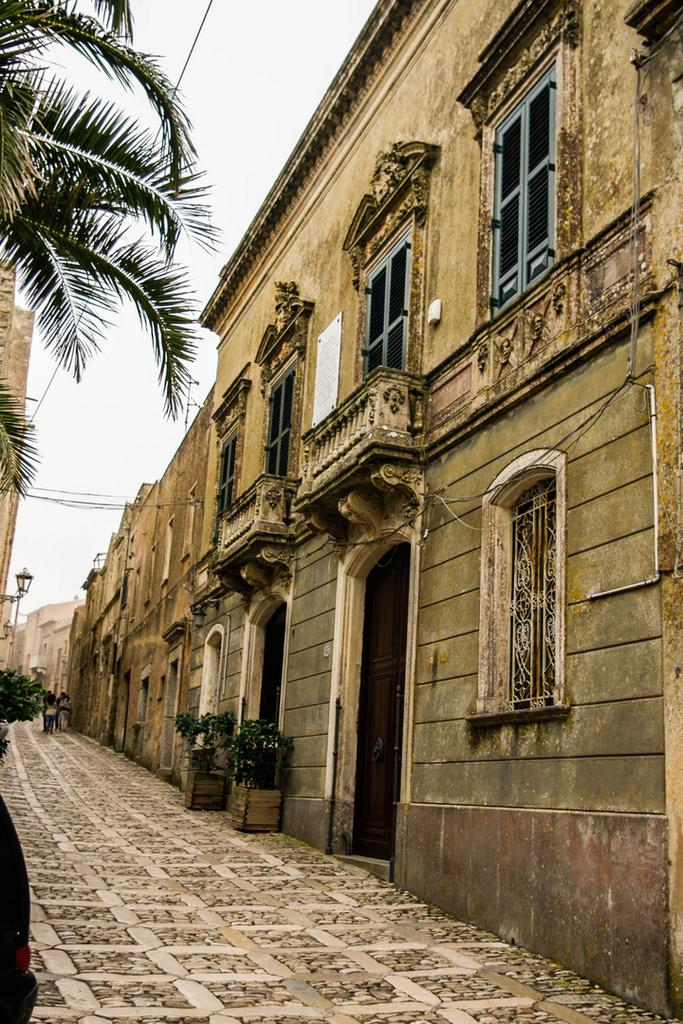What type of structure is present in the image? There is a building in the image. What other elements can be seen in the image besides the building? There are plants, street lamps, and a tree in the image. What is visible at the top of the image? The sky is visible at the top of the image. What type of pollution can be seen in the image? There is no pollution visible in the image. What is the aftermath of the action in the image? There is no action or aftermath present in the image. 